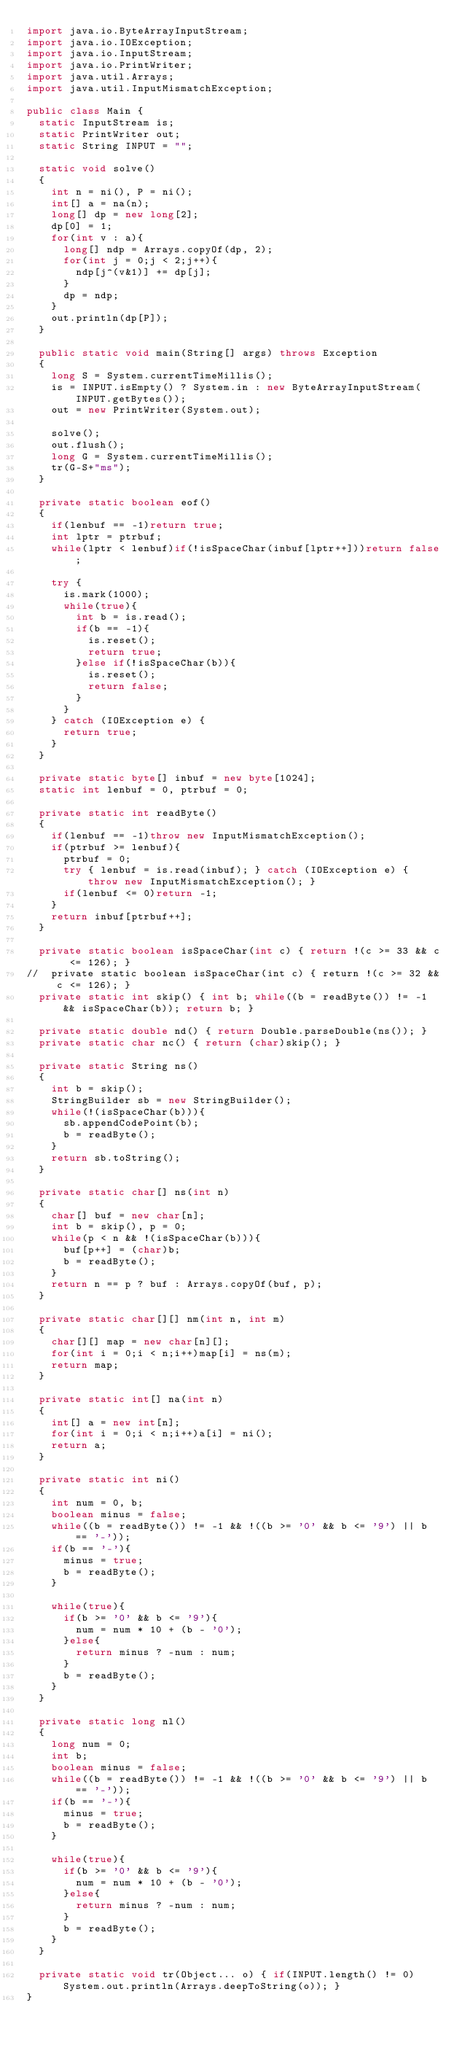Convert code to text. <code><loc_0><loc_0><loc_500><loc_500><_Java_>import java.io.ByteArrayInputStream;
import java.io.IOException;
import java.io.InputStream;
import java.io.PrintWriter;
import java.util.Arrays;
import java.util.InputMismatchException;

public class Main {
	static InputStream is;
	static PrintWriter out;
	static String INPUT = "";
	
	static void solve()
	{
		int n = ni(), P = ni();
		int[] a = na(n);
		long[] dp = new long[2];
		dp[0] = 1;
		for(int v : a){
			long[] ndp = Arrays.copyOf(dp, 2);
			for(int j = 0;j < 2;j++){
				ndp[j^(v&1)] += dp[j];
			}
			dp = ndp;
		}
		out.println(dp[P]);
	}
	
	public static void main(String[] args) throws Exception
	{
		long S = System.currentTimeMillis();
		is = INPUT.isEmpty() ? System.in : new ByteArrayInputStream(INPUT.getBytes());
		out = new PrintWriter(System.out);
		
		solve();
		out.flush();
		long G = System.currentTimeMillis();
		tr(G-S+"ms");
	}
	
	private static boolean eof()
	{
		if(lenbuf == -1)return true;
		int lptr = ptrbuf;
		while(lptr < lenbuf)if(!isSpaceChar(inbuf[lptr++]))return false;
		
		try {
			is.mark(1000);
			while(true){
				int b = is.read();
				if(b == -1){
					is.reset();
					return true;
				}else if(!isSpaceChar(b)){
					is.reset();
					return false;
				}
			}
		} catch (IOException e) {
			return true;
		}
	}
	
	private static byte[] inbuf = new byte[1024];
	static int lenbuf = 0, ptrbuf = 0;
	
	private static int readByte()
	{
		if(lenbuf == -1)throw new InputMismatchException();
		if(ptrbuf >= lenbuf){
			ptrbuf = 0;
			try { lenbuf = is.read(inbuf); } catch (IOException e) { throw new InputMismatchException(); }
			if(lenbuf <= 0)return -1;
		}
		return inbuf[ptrbuf++];
	}
	
	private static boolean isSpaceChar(int c) { return !(c >= 33 && c <= 126); }
//	private static boolean isSpaceChar(int c) { return !(c >= 32 && c <= 126); }
	private static int skip() { int b; while((b = readByte()) != -1 && isSpaceChar(b)); return b; }
	
	private static double nd() { return Double.parseDouble(ns()); }
	private static char nc() { return (char)skip(); }
	
	private static String ns()
	{
		int b = skip();
		StringBuilder sb = new StringBuilder();
		while(!(isSpaceChar(b))){
			sb.appendCodePoint(b);
			b = readByte();
		}
		return sb.toString();
	}
	
	private static char[] ns(int n)
	{
		char[] buf = new char[n];
		int b = skip(), p = 0;
		while(p < n && !(isSpaceChar(b))){
			buf[p++] = (char)b;
			b = readByte();
		}
		return n == p ? buf : Arrays.copyOf(buf, p);
	}
	
	private static char[][] nm(int n, int m)
	{
		char[][] map = new char[n][];
		for(int i = 0;i < n;i++)map[i] = ns(m);
		return map;
	}
	
	private static int[] na(int n)
	{
		int[] a = new int[n];
		for(int i = 0;i < n;i++)a[i] = ni();
		return a;
	}
	
	private static int ni()
	{
		int num = 0, b;
		boolean minus = false;
		while((b = readByte()) != -1 && !((b >= '0' && b <= '9') || b == '-'));
		if(b == '-'){
			minus = true;
			b = readByte();
		}
		
		while(true){
			if(b >= '0' && b <= '9'){
				num = num * 10 + (b - '0');
			}else{
				return minus ? -num : num;
			}
			b = readByte();
		}
	}
	
	private static long nl()
	{
		long num = 0;
		int b;
		boolean minus = false;
		while((b = readByte()) != -1 && !((b >= '0' && b <= '9') || b == '-'));
		if(b == '-'){
			minus = true;
			b = readByte();
		}
		
		while(true){
			if(b >= '0' && b <= '9'){
				num = num * 10 + (b - '0');
			}else{
				return minus ? -num : num;
			}
			b = readByte();
		}
	}
	
	private static void tr(Object... o) { if(INPUT.length() != 0)System.out.println(Arrays.deepToString(o)); }
}
</code> 